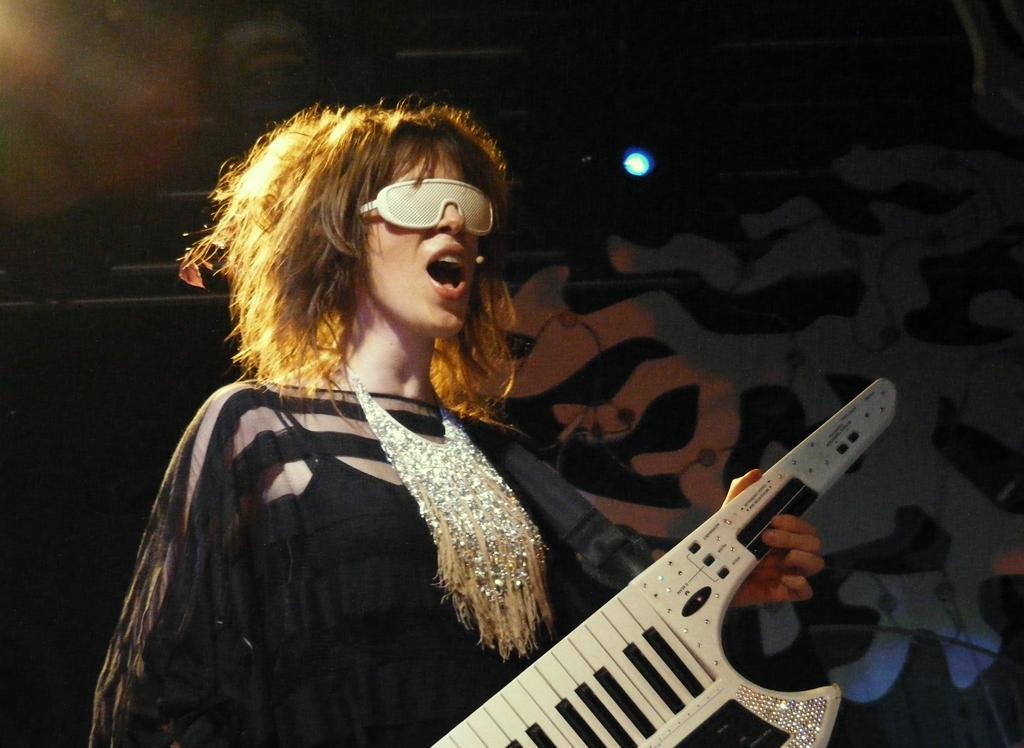How would you summarize this image in a sentence or two? There is a woman in black color dress holding a musical instrument and playing and standing on a stage. In the background, there is a light which is attached to the wall on which, there is a painting. And the background is dark in color. 